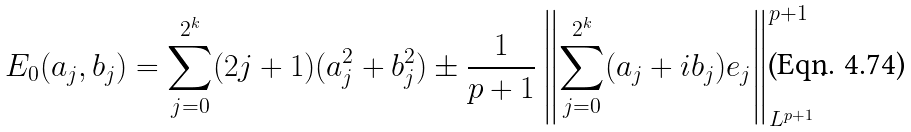Convert formula to latex. <formula><loc_0><loc_0><loc_500><loc_500>E _ { 0 } ( a _ { j } , b _ { j } ) = \sum _ { j = 0 } ^ { 2 ^ { k } } ( 2 j + 1 ) ( a _ { j } ^ { 2 } + b _ { j } ^ { 2 } ) \pm \frac { 1 } { p + 1 } \left \| \sum _ { j = 0 } ^ { 2 ^ { k } } ( a _ { j } + i b _ { j } ) e _ { j } \right \| _ { L ^ { p + 1 } } ^ { p + 1 } .</formula> 